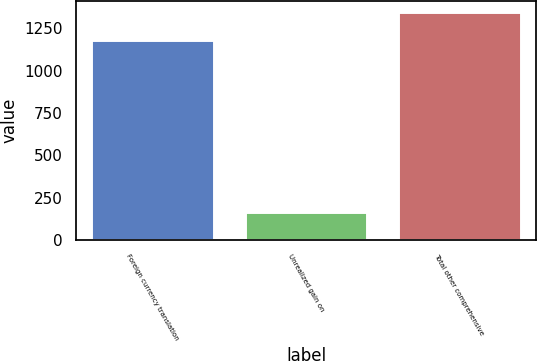Convert chart. <chart><loc_0><loc_0><loc_500><loc_500><bar_chart><fcel>Foreign currency translation<fcel>Unrealized gain on<fcel>Total other comprehensive<nl><fcel>1183<fcel>164<fcel>1347<nl></chart> 